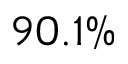Convert formula to latex. <formula><loc_0><loc_0><loc_500><loc_500>9 0 . 1 \%</formula> 